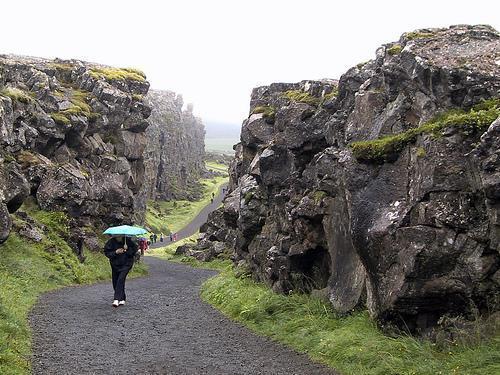How many buses are there going to max north?
Give a very brief answer. 0. 